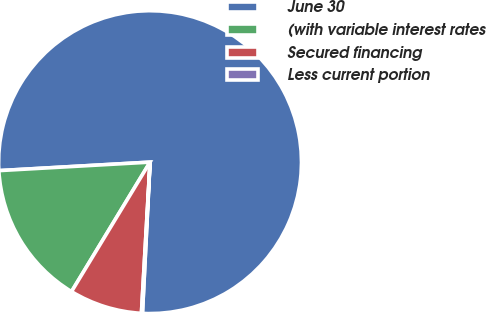<chart> <loc_0><loc_0><loc_500><loc_500><pie_chart><fcel>June 30<fcel>(with variable interest rates<fcel>Secured financing<fcel>Less current portion<nl><fcel>76.7%<fcel>15.43%<fcel>7.77%<fcel>0.11%<nl></chart> 